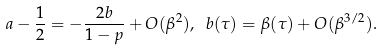Convert formula to latex. <formula><loc_0><loc_0><loc_500><loc_500>a - \frac { 1 } { 2 } = - \frac { 2 b } { 1 - p } + O ( \beta ^ { 2 } ) , \ b ( \tau ) = \beta ( \tau ) + O ( \beta ^ { 3 / 2 } ) .</formula> 